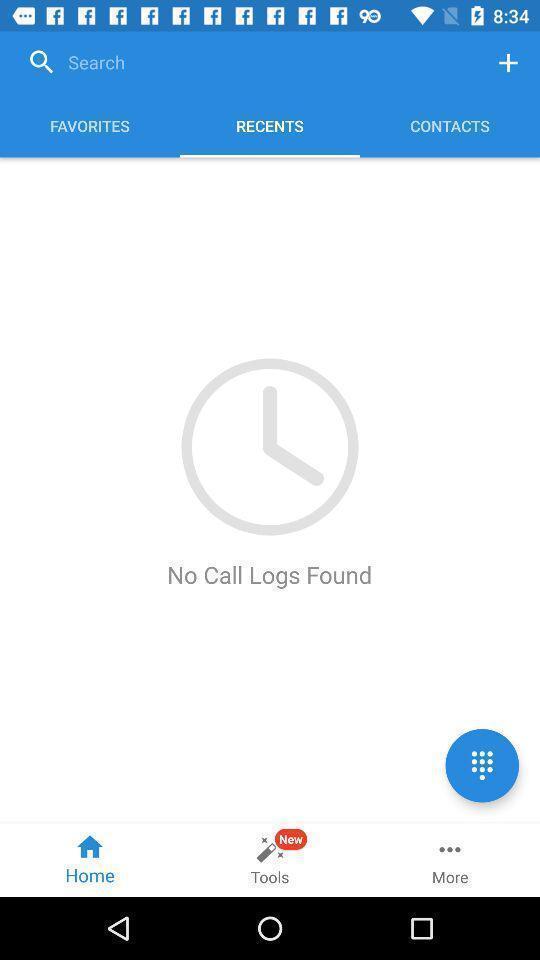Summarize the information in this screenshot. Screen shows no recent call logs. 